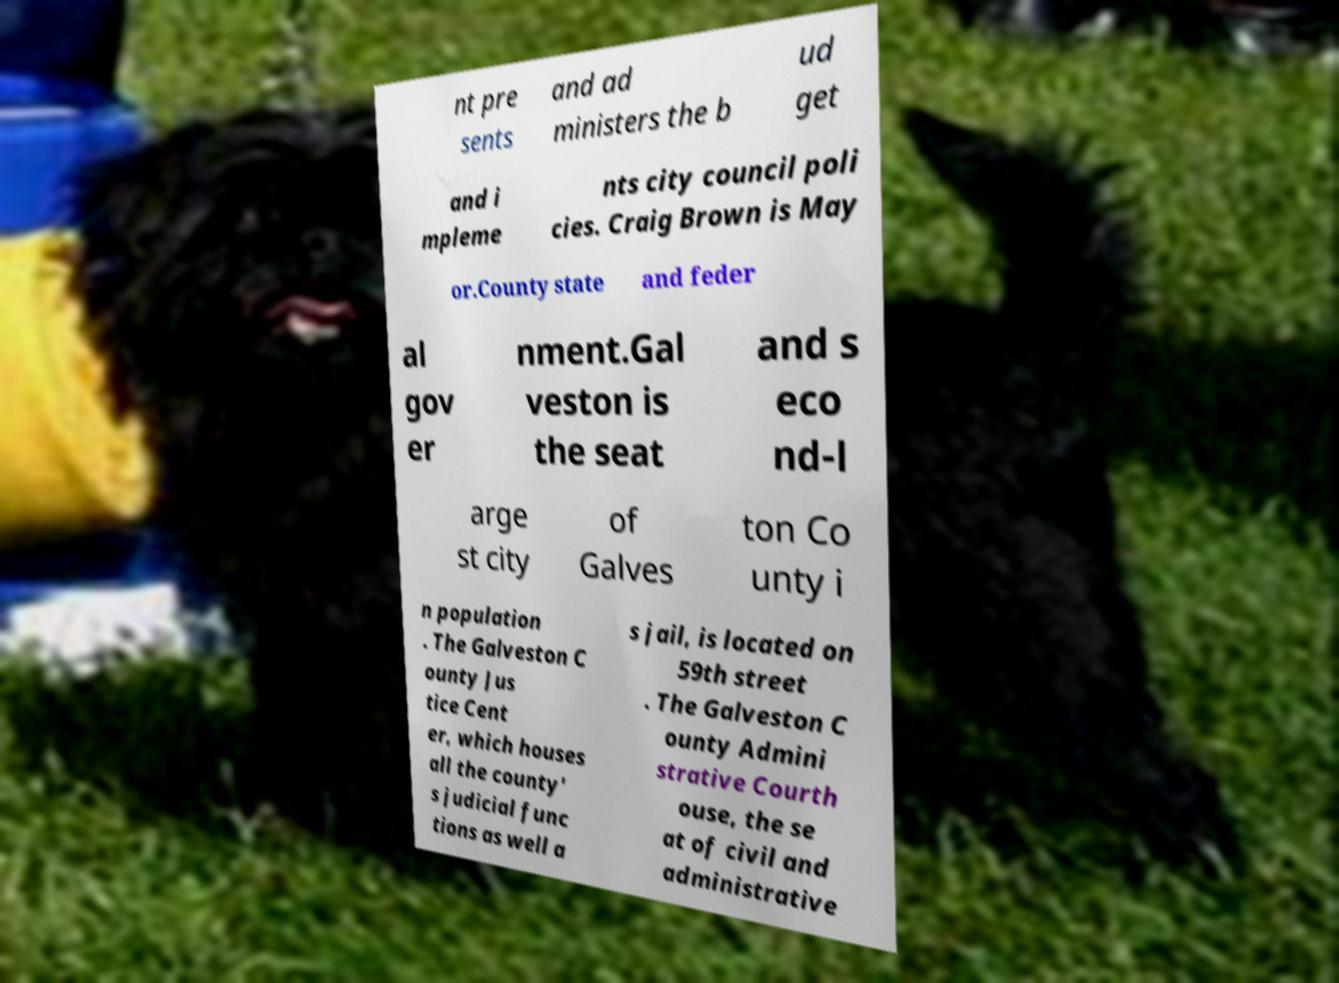Could you extract and type out the text from this image? nt pre sents and ad ministers the b ud get and i mpleme nts city council poli cies. Craig Brown is May or.County state and feder al gov er nment.Gal veston is the seat and s eco nd-l arge st city of Galves ton Co unty i n population . The Galveston C ounty Jus tice Cent er, which houses all the county' s judicial func tions as well a s jail, is located on 59th street . The Galveston C ounty Admini strative Courth ouse, the se at of civil and administrative 